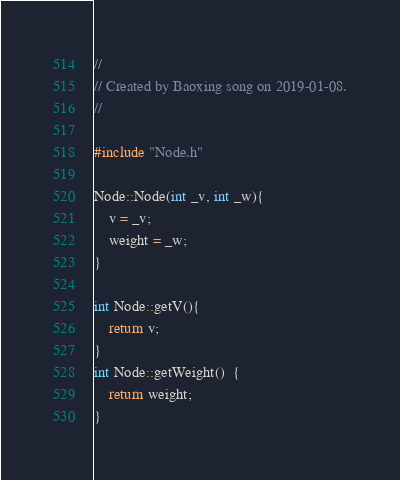Convert code to text. <code><loc_0><loc_0><loc_500><loc_500><_C++_>//
// Created by Baoxing song on 2019-01-08.
//

#include "Node.h"

Node::Node(int _v, int _w){
    v = _v;
    weight = _w;
}

int Node::getV(){
    return v;
}
int Node::getWeight()  {
    return weight;
}
</code> 